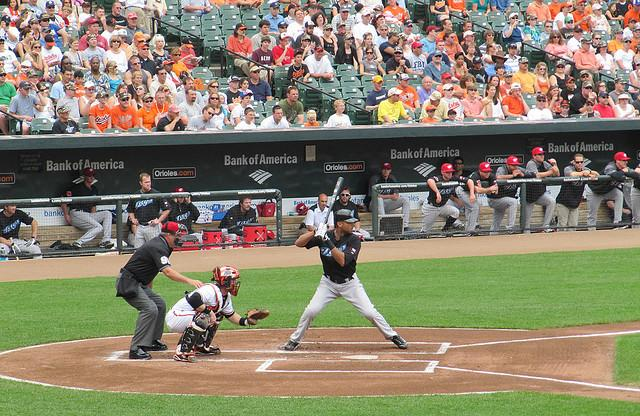What color is the umpire's helmet who is standing with his hand on the catcher's back? Please explain your reasoning. red. The one with his hand on the other player's back is wearing scarlet head ware. 